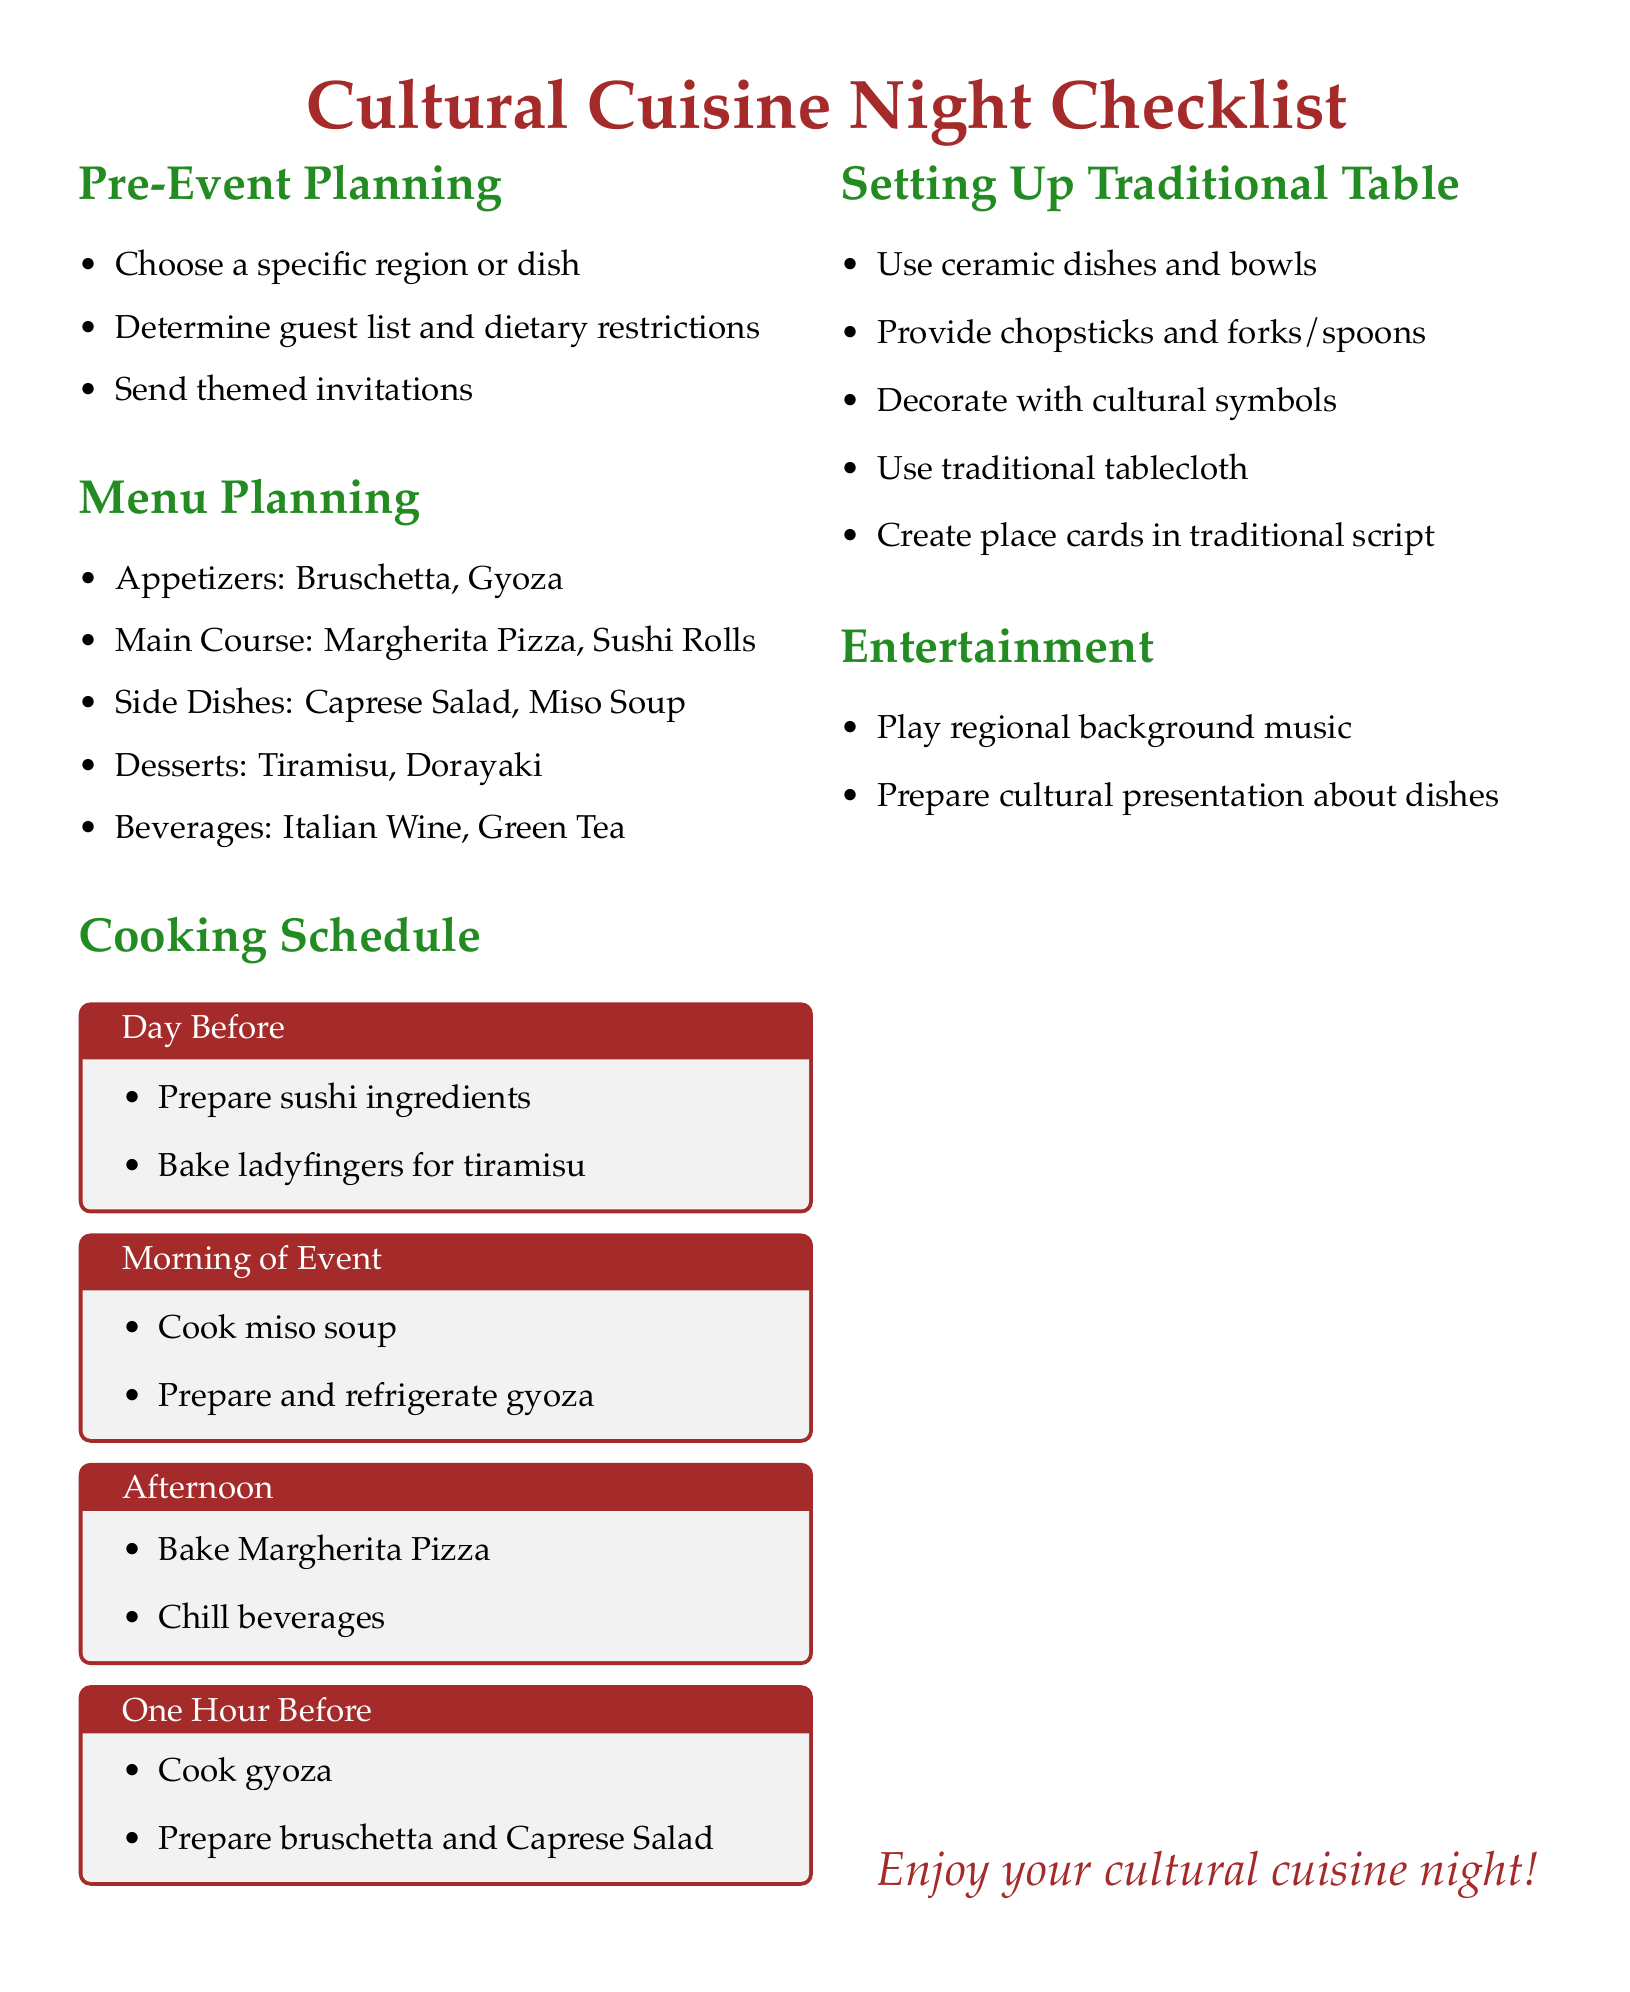what is the theme of the dinner party? The theme is specified as "Cultural Cuisine Night" at the top of the document.
Answer: Cultural Cuisine Night how many appetizers are listed in the menu? The list of appetizers includes two items: Bruschetta and Gyoza.
Answer: 2 what is one of the desserts suggested? Tiramisu is listed as one of the desserts in the menu.
Answer: Tiramisu what needs to be prepared one day before the event? The document specifies two tasks: Preparing sushi ingredients and baking ladyfingers for tiramisu.
Answer: Sushi ingredients, ladyfingers what types of dishes are recommended for the main course? The document lists specific dishes for the main course, which are Margherita Pizza and Sushi Rolls.
Answer: Margherita Pizza, Sushi Rolls how should the table be decorated according to the checklist? The checklist mentions decorating with cultural symbols.
Answer: Cultural symbols what is provided alongside ceramic dishes at the traditional table setup? The document states that chopsticks and forks/spoons are provided.
Answer: Chopsticks and forks/spoons what type of music is suggested for entertainment? It is recommended to play regional background music during the event.
Answer: Regional background music which dish should be cooked one hour before the event? The checklist specifies cooking gyoza one hour before the event.
Answer: Gyoza 